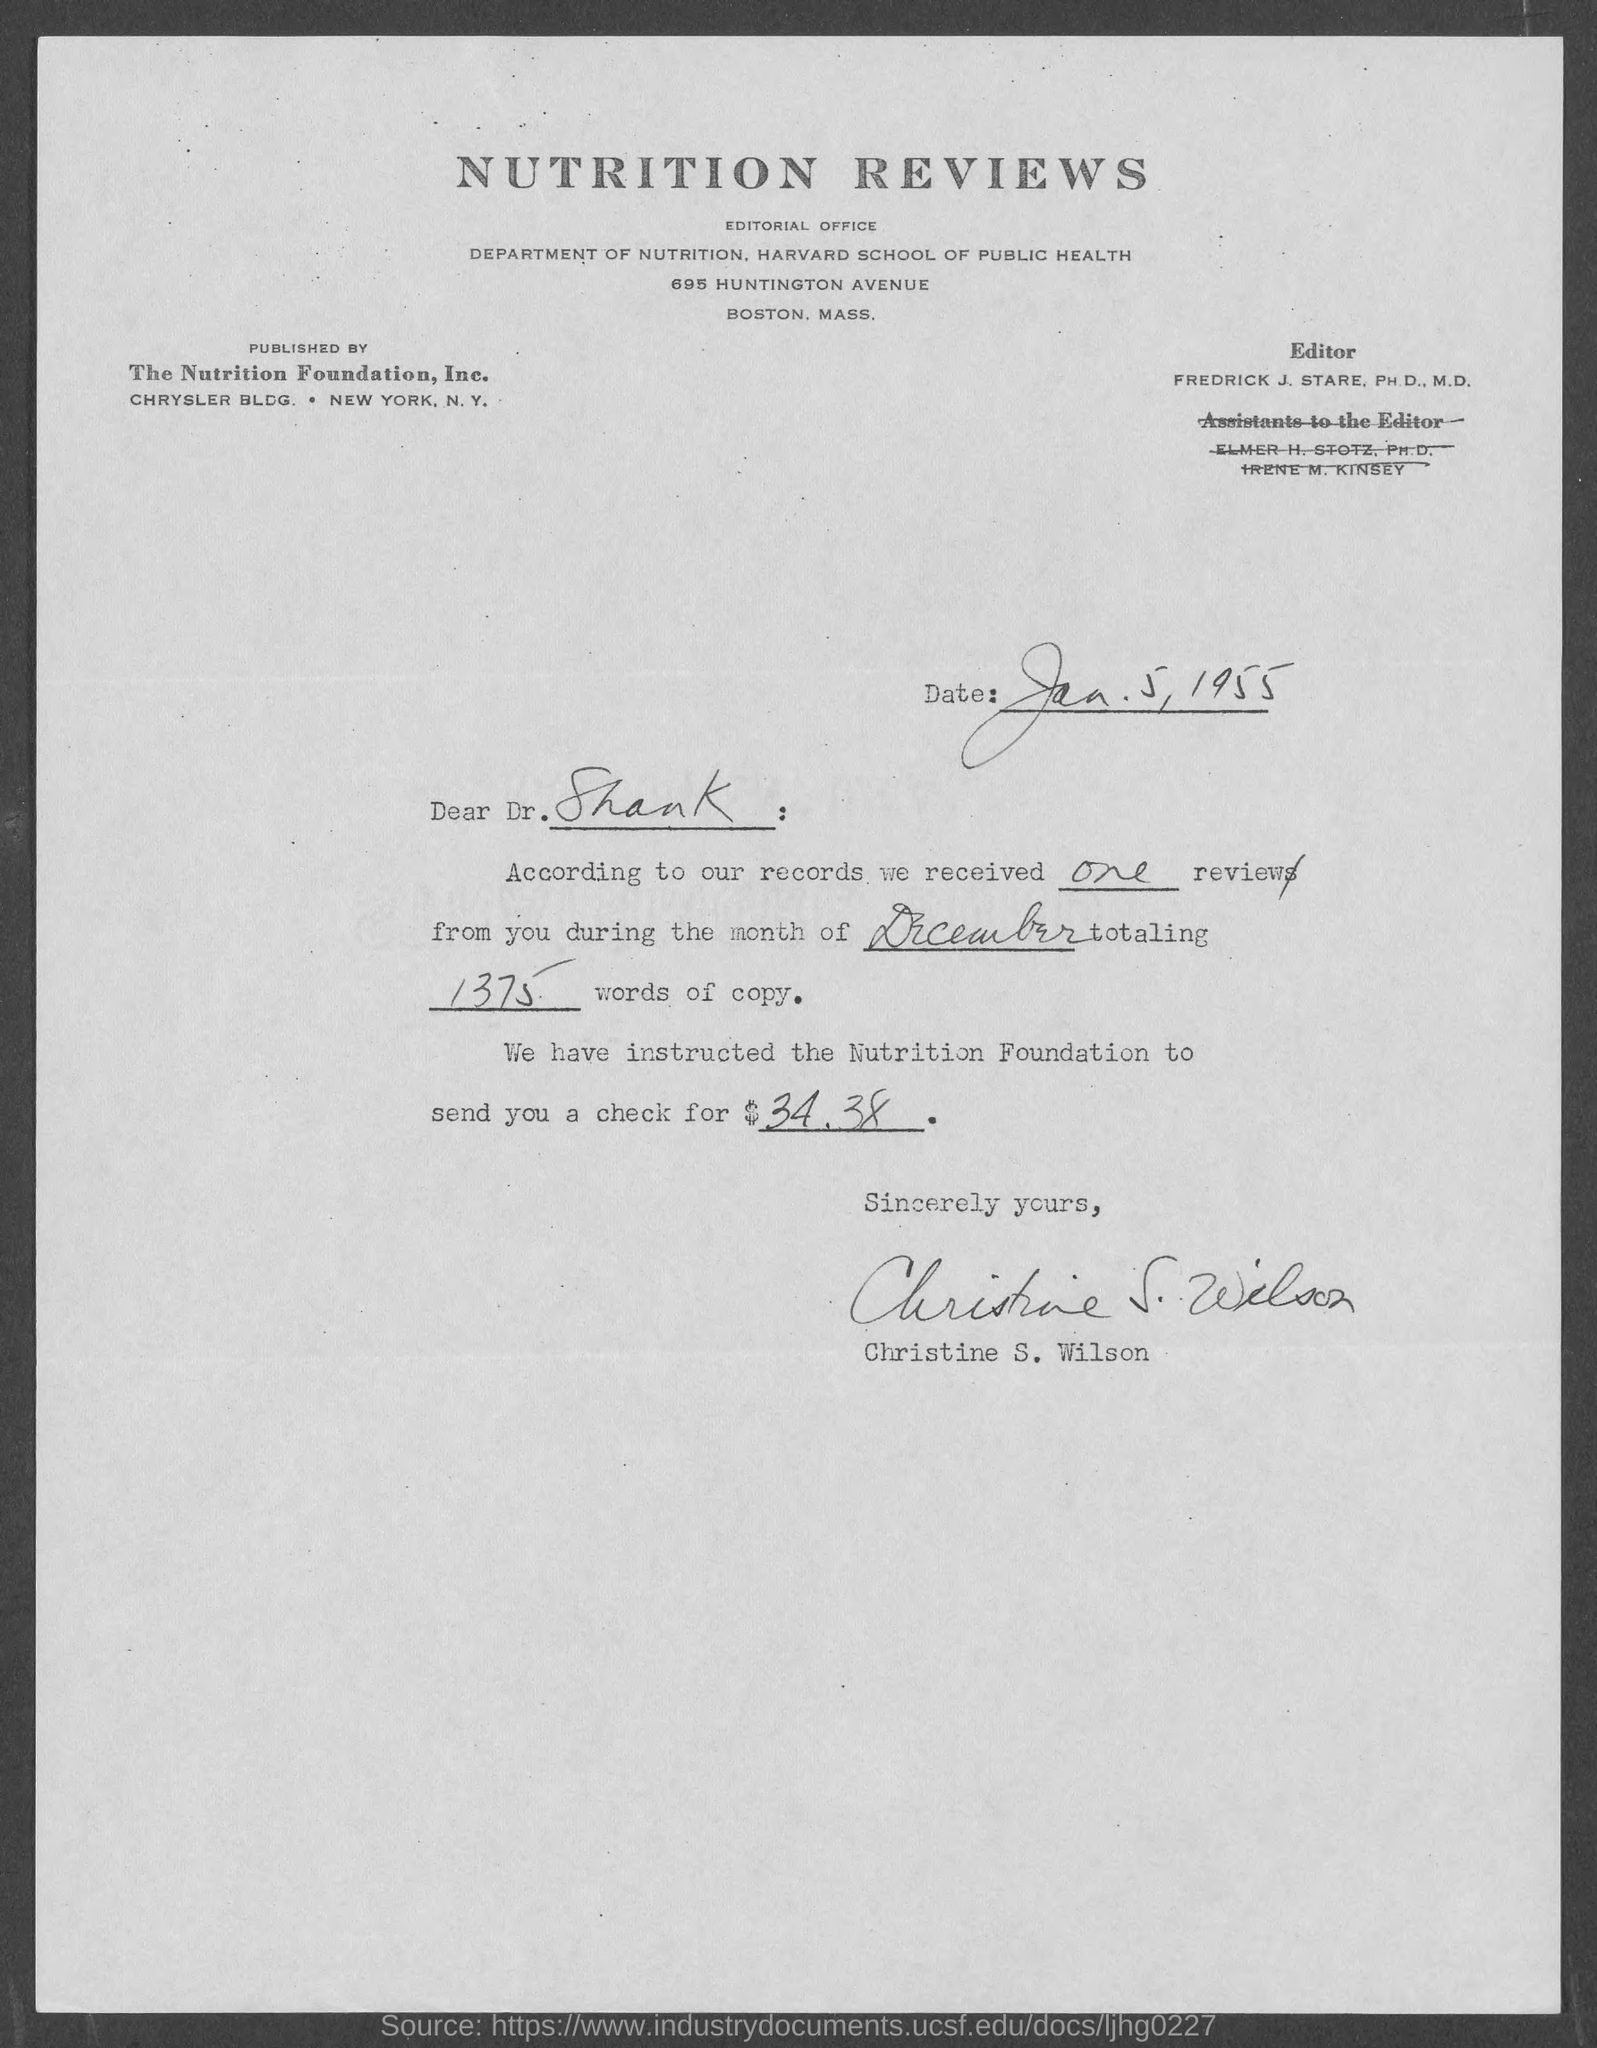Indicate a few pertinent items in this graphic. The document title is Nutrition Reviews. Dr. Frederick J. Stare, a Ph.D. and M.D. doctor, is the editor. The Nutrition Foundation, Inc. is the publisher of the article. The sender is Christine S. Wilson. The letter is addressed to Dr. Shank. 